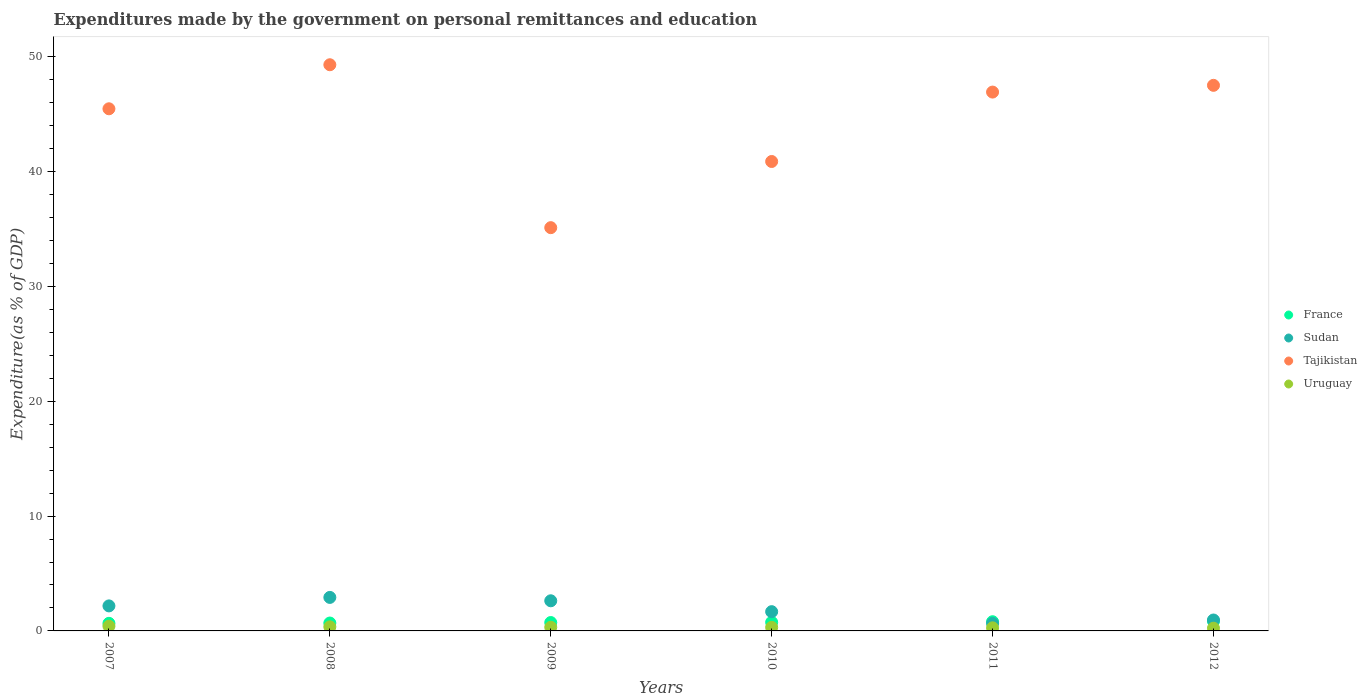How many different coloured dotlines are there?
Provide a short and direct response. 4. Is the number of dotlines equal to the number of legend labels?
Give a very brief answer. Yes. What is the expenditures made by the government on personal remittances and education in Tajikistan in 2010?
Provide a short and direct response. 40.87. Across all years, what is the maximum expenditures made by the government on personal remittances and education in Sudan?
Your response must be concise. 2.92. Across all years, what is the minimum expenditures made by the government on personal remittances and education in France?
Offer a very short reply. 0.66. In which year was the expenditures made by the government on personal remittances and education in France maximum?
Give a very brief answer. 2012. In which year was the expenditures made by the government on personal remittances and education in Sudan minimum?
Provide a succinct answer. 2011. What is the total expenditures made by the government on personal remittances and education in Uruguay in the graph?
Your answer should be very brief. 1.9. What is the difference between the expenditures made by the government on personal remittances and education in France in 2009 and that in 2012?
Keep it short and to the point. -0.12. What is the difference between the expenditures made by the government on personal remittances and education in France in 2008 and the expenditures made by the government on personal remittances and education in Uruguay in 2010?
Your answer should be very brief. 0.38. What is the average expenditures made by the government on personal remittances and education in Tajikistan per year?
Offer a very short reply. 44.19. In the year 2010, what is the difference between the expenditures made by the government on personal remittances and education in Sudan and expenditures made by the government on personal remittances and education in Tajikistan?
Ensure brevity in your answer.  -39.19. What is the ratio of the expenditures made by the government on personal remittances and education in Tajikistan in 2009 to that in 2010?
Keep it short and to the point. 0.86. Is the difference between the expenditures made by the government on personal remittances and education in Sudan in 2007 and 2011 greater than the difference between the expenditures made by the government on personal remittances and education in Tajikistan in 2007 and 2011?
Give a very brief answer. Yes. What is the difference between the highest and the second highest expenditures made by the government on personal remittances and education in France?
Your answer should be compact. 0.04. What is the difference between the highest and the lowest expenditures made by the government on personal remittances and education in France?
Offer a very short reply. 0.19. Is it the case that in every year, the sum of the expenditures made by the government on personal remittances and education in France and expenditures made by the government on personal remittances and education in Uruguay  is greater than the expenditures made by the government on personal remittances and education in Tajikistan?
Keep it short and to the point. No. How many years are there in the graph?
Provide a short and direct response. 6. Does the graph contain any zero values?
Provide a short and direct response. No. Does the graph contain grids?
Keep it short and to the point. No. Where does the legend appear in the graph?
Make the answer very short. Center right. How are the legend labels stacked?
Provide a succinct answer. Vertical. What is the title of the graph?
Make the answer very short. Expenditures made by the government on personal remittances and education. What is the label or title of the Y-axis?
Your answer should be very brief. Expenditure(as % of GDP). What is the Expenditure(as % of GDP) in France in 2007?
Offer a terse response. 0.66. What is the Expenditure(as % of GDP) in Sudan in 2007?
Give a very brief answer. 2.18. What is the Expenditure(as % of GDP) in Tajikistan in 2007?
Your answer should be compact. 45.46. What is the Expenditure(as % of GDP) in Uruguay in 2007?
Make the answer very short. 0.41. What is the Expenditure(as % of GDP) in France in 2008?
Provide a short and direct response. 0.69. What is the Expenditure(as % of GDP) of Sudan in 2008?
Your answer should be very brief. 2.92. What is the Expenditure(as % of GDP) of Tajikistan in 2008?
Give a very brief answer. 49.29. What is the Expenditure(as % of GDP) of Uruguay in 2008?
Provide a short and direct response. 0.36. What is the Expenditure(as % of GDP) in France in 2009?
Your response must be concise. 0.73. What is the Expenditure(as % of GDP) of Sudan in 2009?
Make the answer very short. 2.62. What is the Expenditure(as % of GDP) of Tajikistan in 2009?
Your answer should be compact. 35.11. What is the Expenditure(as % of GDP) of Uruguay in 2009?
Your response must be concise. 0.32. What is the Expenditure(as % of GDP) in France in 2010?
Your response must be concise. 0.75. What is the Expenditure(as % of GDP) of Sudan in 2010?
Ensure brevity in your answer.  1.68. What is the Expenditure(as % of GDP) in Tajikistan in 2010?
Give a very brief answer. 40.87. What is the Expenditure(as % of GDP) in Uruguay in 2010?
Offer a very short reply. 0.31. What is the Expenditure(as % of GDP) of France in 2011?
Your response must be concise. 0.8. What is the Expenditure(as % of GDP) of Sudan in 2011?
Ensure brevity in your answer.  0.66. What is the Expenditure(as % of GDP) of Tajikistan in 2011?
Your answer should be compact. 46.91. What is the Expenditure(as % of GDP) of Uruguay in 2011?
Provide a succinct answer. 0.27. What is the Expenditure(as % of GDP) of France in 2012?
Your answer should be very brief. 0.85. What is the Expenditure(as % of GDP) in Sudan in 2012?
Make the answer very short. 0.95. What is the Expenditure(as % of GDP) in Tajikistan in 2012?
Provide a succinct answer. 47.5. What is the Expenditure(as % of GDP) in Uruguay in 2012?
Provide a succinct answer. 0.24. Across all years, what is the maximum Expenditure(as % of GDP) of France?
Ensure brevity in your answer.  0.85. Across all years, what is the maximum Expenditure(as % of GDP) in Sudan?
Your answer should be very brief. 2.92. Across all years, what is the maximum Expenditure(as % of GDP) in Tajikistan?
Your answer should be compact. 49.29. Across all years, what is the maximum Expenditure(as % of GDP) in Uruguay?
Your answer should be compact. 0.41. Across all years, what is the minimum Expenditure(as % of GDP) of France?
Ensure brevity in your answer.  0.66. Across all years, what is the minimum Expenditure(as % of GDP) in Sudan?
Offer a very short reply. 0.66. Across all years, what is the minimum Expenditure(as % of GDP) of Tajikistan?
Make the answer very short. 35.11. Across all years, what is the minimum Expenditure(as % of GDP) of Uruguay?
Ensure brevity in your answer.  0.24. What is the total Expenditure(as % of GDP) in France in the graph?
Your response must be concise. 4.48. What is the total Expenditure(as % of GDP) of Sudan in the graph?
Offer a terse response. 11. What is the total Expenditure(as % of GDP) in Tajikistan in the graph?
Your answer should be compact. 265.13. What is the total Expenditure(as % of GDP) in Uruguay in the graph?
Offer a very short reply. 1.9. What is the difference between the Expenditure(as % of GDP) of France in 2007 and that in 2008?
Your answer should be very brief. -0.03. What is the difference between the Expenditure(as % of GDP) in Sudan in 2007 and that in 2008?
Your answer should be very brief. -0.74. What is the difference between the Expenditure(as % of GDP) of Tajikistan in 2007 and that in 2008?
Offer a terse response. -3.83. What is the difference between the Expenditure(as % of GDP) of Uruguay in 2007 and that in 2008?
Offer a terse response. 0.06. What is the difference between the Expenditure(as % of GDP) of France in 2007 and that in 2009?
Offer a very short reply. -0.07. What is the difference between the Expenditure(as % of GDP) of Sudan in 2007 and that in 2009?
Keep it short and to the point. -0.45. What is the difference between the Expenditure(as % of GDP) of Tajikistan in 2007 and that in 2009?
Keep it short and to the point. 10.35. What is the difference between the Expenditure(as % of GDP) in Uruguay in 2007 and that in 2009?
Your answer should be compact. 0.09. What is the difference between the Expenditure(as % of GDP) of France in 2007 and that in 2010?
Your response must be concise. -0.09. What is the difference between the Expenditure(as % of GDP) in Sudan in 2007 and that in 2010?
Make the answer very short. 0.5. What is the difference between the Expenditure(as % of GDP) of Tajikistan in 2007 and that in 2010?
Ensure brevity in your answer.  4.59. What is the difference between the Expenditure(as % of GDP) in Uruguay in 2007 and that in 2010?
Keep it short and to the point. 0.1. What is the difference between the Expenditure(as % of GDP) of France in 2007 and that in 2011?
Offer a terse response. -0.14. What is the difference between the Expenditure(as % of GDP) of Sudan in 2007 and that in 2011?
Provide a short and direct response. 1.52. What is the difference between the Expenditure(as % of GDP) in Tajikistan in 2007 and that in 2011?
Offer a very short reply. -1.45. What is the difference between the Expenditure(as % of GDP) in Uruguay in 2007 and that in 2011?
Give a very brief answer. 0.14. What is the difference between the Expenditure(as % of GDP) in France in 2007 and that in 2012?
Provide a short and direct response. -0.19. What is the difference between the Expenditure(as % of GDP) in Sudan in 2007 and that in 2012?
Make the answer very short. 1.23. What is the difference between the Expenditure(as % of GDP) of Tajikistan in 2007 and that in 2012?
Keep it short and to the point. -2.04. What is the difference between the Expenditure(as % of GDP) in Uruguay in 2007 and that in 2012?
Make the answer very short. 0.18. What is the difference between the Expenditure(as % of GDP) of France in 2008 and that in 2009?
Your response must be concise. -0.04. What is the difference between the Expenditure(as % of GDP) in Sudan in 2008 and that in 2009?
Your answer should be very brief. 0.29. What is the difference between the Expenditure(as % of GDP) of Tajikistan in 2008 and that in 2009?
Offer a terse response. 14.18. What is the difference between the Expenditure(as % of GDP) in Uruguay in 2008 and that in 2009?
Your response must be concise. 0.04. What is the difference between the Expenditure(as % of GDP) of France in 2008 and that in 2010?
Offer a terse response. -0.06. What is the difference between the Expenditure(as % of GDP) of Sudan in 2008 and that in 2010?
Make the answer very short. 1.24. What is the difference between the Expenditure(as % of GDP) in Tajikistan in 2008 and that in 2010?
Your response must be concise. 8.42. What is the difference between the Expenditure(as % of GDP) in Uruguay in 2008 and that in 2010?
Keep it short and to the point. 0.05. What is the difference between the Expenditure(as % of GDP) of France in 2008 and that in 2011?
Provide a short and direct response. -0.11. What is the difference between the Expenditure(as % of GDP) of Sudan in 2008 and that in 2011?
Make the answer very short. 2.26. What is the difference between the Expenditure(as % of GDP) in Tajikistan in 2008 and that in 2011?
Offer a terse response. 2.38. What is the difference between the Expenditure(as % of GDP) of Uruguay in 2008 and that in 2011?
Ensure brevity in your answer.  0.09. What is the difference between the Expenditure(as % of GDP) of France in 2008 and that in 2012?
Provide a succinct answer. -0.16. What is the difference between the Expenditure(as % of GDP) of Sudan in 2008 and that in 2012?
Provide a short and direct response. 1.97. What is the difference between the Expenditure(as % of GDP) in Tajikistan in 2008 and that in 2012?
Make the answer very short. 1.79. What is the difference between the Expenditure(as % of GDP) in Uruguay in 2008 and that in 2012?
Provide a succinct answer. 0.12. What is the difference between the Expenditure(as % of GDP) of France in 2009 and that in 2010?
Give a very brief answer. -0.02. What is the difference between the Expenditure(as % of GDP) in Sudan in 2009 and that in 2010?
Your answer should be compact. 0.95. What is the difference between the Expenditure(as % of GDP) of Tajikistan in 2009 and that in 2010?
Your answer should be compact. -5.76. What is the difference between the Expenditure(as % of GDP) of Uruguay in 2009 and that in 2010?
Offer a terse response. 0.01. What is the difference between the Expenditure(as % of GDP) of France in 2009 and that in 2011?
Give a very brief answer. -0.07. What is the difference between the Expenditure(as % of GDP) of Sudan in 2009 and that in 2011?
Your answer should be compact. 1.97. What is the difference between the Expenditure(as % of GDP) of Tajikistan in 2009 and that in 2011?
Offer a terse response. -11.8. What is the difference between the Expenditure(as % of GDP) of Uruguay in 2009 and that in 2011?
Your response must be concise. 0.05. What is the difference between the Expenditure(as % of GDP) in France in 2009 and that in 2012?
Offer a terse response. -0.12. What is the difference between the Expenditure(as % of GDP) in Sudan in 2009 and that in 2012?
Give a very brief answer. 1.67. What is the difference between the Expenditure(as % of GDP) of Tajikistan in 2009 and that in 2012?
Provide a short and direct response. -12.39. What is the difference between the Expenditure(as % of GDP) in Uruguay in 2009 and that in 2012?
Give a very brief answer. 0.08. What is the difference between the Expenditure(as % of GDP) in France in 2010 and that in 2011?
Make the answer very short. -0.05. What is the difference between the Expenditure(as % of GDP) of Sudan in 2010 and that in 2011?
Offer a very short reply. 1.02. What is the difference between the Expenditure(as % of GDP) in Tajikistan in 2010 and that in 2011?
Your answer should be compact. -6.04. What is the difference between the Expenditure(as % of GDP) in Uruguay in 2010 and that in 2011?
Your answer should be very brief. 0.04. What is the difference between the Expenditure(as % of GDP) of France in 2010 and that in 2012?
Give a very brief answer. -0.09. What is the difference between the Expenditure(as % of GDP) in Sudan in 2010 and that in 2012?
Keep it short and to the point. 0.73. What is the difference between the Expenditure(as % of GDP) of Tajikistan in 2010 and that in 2012?
Offer a terse response. -6.63. What is the difference between the Expenditure(as % of GDP) in Uruguay in 2010 and that in 2012?
Offer a very short reply. 0.07. What is the difference between the Expenditure(as % of GDP) in France in 2011 and that in 2012?
Your answer should be compact. -0.04. What is the difference between the Expenditure(as % of GDP) in Sudan in 2011 and that in 2012?
Make the answer very short. -0.29. What is the difference between the Expenditure(as % of GDP) in Tajikistan in 2011 and that in 2012?
Offer a terse response. -0.59. What is the difference between the Expenditure(as % of GDP) of Uruguay in 2011 and that in 2012?
Provide a short and direct response. 0.03. What is the difference between the Expenditure(as % of GDP) of France in 2007 and the Expenditure(as % of GDP) of Sudan in 2008?
Your response must be concise. -2.26. What is the difference between the Expenditure(as % of GDP) of France in 2007 and the Expenditure(as % of GDP) of Tajikistan in 2008?
Offer a terse response. -48.63. What is the difference between the Expenditure(as % of GDP) of France in 2007 and the Expenditure(as % of GDP) of Uruguay in 2008?
Provide a short and direct response. 0.31. What is the difference between the Expenditure(as % of GDP) of Sudan in 2007 and the Expenditure(as % of GDP) of Tajikistan in 2008?
Provide a short and direct response. -47.11. What is the difference between the Expenditure(as % of GDP) in Sudan in 2007 and the Expenditure(as % of GDP) in Uruguay in 2008?
Provide a short and direct response. 1.82. What is the difference between the Expenditure(as % of GDP) in Tajikistan in 2007 and the Expenditure(as % of GDP) in Uruguay in 2008?
Make the answer very short. 45.1. What is the difference between the Expenditure(as % of GDP) in France in 2007 and the Expenditure(as % of GDP) in Sudan in 2009?
Offer a terse response. -1.96. What is the difference between the Expenditure(as % of GDP) in France in 2007 and the Expenditure(as % of GDP) in Tajikistan in 2009?
Keep it short and to the point. -34.45. What is the difference between the Expenditure(as % of GDP) of France in 2007 and the Expenditure(as % of GDP) of Uruguay in 2009?
Offer a terse response. 0.34. What is the difference between the Expenditure(as % of GDP) in Sudan in 2007 and the Expenditure(as % of GDP) in Tajikistan in 2009?
Make the answer very short. -32.93. What is the difference between the Expenditure(as % of GDP) of Sudan in 2007 and the Expenditure(as % of GDP) of Uruguay in 2009?
Provide a short and direct response. 1.86. What is the difference between the Expenditure(as % of GDP) in Tajikistan in 2007 and the Expenditure(as % of GDP) in Uruguay in 2009?
Ensure brevity in your answer.  45.14. What is the difference between the Expenditure(as % of GDP) in France in 2007 and the Expenditure(as % of GDP) in Sudan in 2010?
Your answer should be compact. -1.02. What is the difference between the Expenditure(as % of GDP) of France in 2007 and the Expenditure(as % of GDP) of Tajikistan in 2010?
Offer a terse response. -40.21. What is the difference between the Expenditure(as % of GDP) of France in 2007 and the Expenditure(as % of GDP) of Uruguay in 2010?
Your response must be concise. 0.35. What is the difference between the Expenditure(as % of GDP) of Sudan in 2007 and the Expenditure(as % of GDP) of Tajikistan in 2010?
Offer a very short reply. -38.69. What is the difference between the Expenditure(as % of GDP) in Sudan in 2007 and the Expenditure(as % of GDP) in Uruguay in 2010?
Keep it short and to the point. 1.87. What is the difference between the Expenditure(as % of GDP) in Tajikistan in 2007 and the Expenditure(as % of GDP) in Uruguay in 2010?
Offer a very short reply. 45.15. What is the difference between the Expenditure(as % of GDP) in France in 2007 and the Expenditure(as % of GDP) in Sudan in 2011?
Make the answer very short. 0. What is the difference between the Expenditure(as % of GDP) in France in 2007 and the Expenditure(as % of GDP) in Tajikistan in 2011?
Your response must be concise. -46.25. What is the difference between the Expenditure(as % of GDP) in France in 2007 and the Expenditure(as % of GDP) in Uruguay in 2011?
Provide a succinct answer. 0.39. What is the difference between the Expenditure(as % of GDP) in Sudan in 2007 and the Expenditure(as % of GDP) in Tajikistan in 2011?
Offer a very short reply. -44.73. What is the difference between the Expenditure(as % of GDP) of Sudan in 2007 and the Expenditure(as % of GDP) of Uruguay in 2011?
Make the answer very short. 1.91. What is the difference between the Expenditure(as % of GDP) of Tajikistan in 2007 and the Expenditure(as % of GDP) of Uruguay in 2011?
Your answer should be compact. 45.19. What is the difference between the Expenditure(as % of GDP) of France in 2007 and the Expenditure(as % of GDP) of Sudan in 2012?
Provide a succinct answer. -0.29. What is the difference between the Expenditure(as % of GDP) in France in 2007 and the Expenditure(as % of GDP) in Tajikistan in 2012?
Your response must be concise. -46.84. What is the difference between the Expenditure(as % of GDP) of France in 2007 and the Expenditure(as % of GDP) of Uruguay in 2012?
Offer a terse response. 0.42. What is the difference between the Expenditure(as % of GDP) of Sudan in 2007 and the Expenditure(as % of GDP) of Tajikistan in 2012?
Your response must be concise. -45.32. What is the difference between the Expenditure(as % of GDP) in Sudan in 2007 and the Expenditure(as % of GDP) in Uruguay in 2012?
Make the answer very short. 1.94. What is the difference between the Expenditure(as % of GDP) in Tajikistan in 2007 and the Expenditure(as % of GDP) in Uruguay in 2012?
Provide a short and direct response. 45.22. What is the difference between the Expenditure(as % of GDP) of France in 2008 and the Expenditure(as % of GDP) of Sudan in 2009?
Keep it short and to the point. -1.94. What is the difference between the Expenditure(as % of GDP) of France in 2008 and the Expenditure(as % of GDP) of Tajikistan in 2009?
Ensure brevity in your answer.  -34.42. What is the difference between the Expenditure(as % of GDP) in France in 2008 and the Expenditure(as % of GDP) in Uruguay in 2009?
Your answer should be compact. 0.37. What is the difference between the Expenditure(as % of GDP) of Sudan in 2008 and the Expenditure(as % of GDP) of Tajikistan in 2009?
Ensure brevity in your answer.  -32.19. What is the difference between the Expenditure(as % of GDP) in Sudan in 2008 and the Expenditure(as % of GDP) in Uruguay in 2009?
Your answer should be very brief. 2.6. What is the difference between the Expenditure(as % of GDP) in Tajikistan in 2008 and the Expenditure(as % of GDP) in Uruguay in 2009?
Provide a succinct answer. 48.97. What is the difference between the Expenditure(as % of GDP) of France in 2008 and the Expenditure(as % of GDP) of Sudan in 2010?
Provide a short and direct response. -0.99. What is the difference between the Expenditure(as % of GDP) of France in 2008 and the Expenditure(as % of GDP) of Tajikistan in 2010?
Provide a short and direct response. -40.18. What is the difference between the Expenditure(as % of GDP) in France in 2008 and the Expenditure(as % of GDP) in Uruguay in 2010?
Offer a terse response. 0.38. What is the difference between the Expenditure(as % of GDP) of Sudan in 2008 and the Expenditure(as % of GDP) of Tajikistan in 2010?
Your answer should be compact. -37.95. What is the difference between the Expenditure(as % of GDP) in Sudan in 2008 and the Expenditure(as % of GDP) in Uruguay in 2010?
Provide a succinct answer. 2.61. What is the difference between the Expenditure(as % of GDP) in Tajikistan in 2008 and the Expenditure(as % of GDP) in Uruguay in 2010?
Make the answer very short. 48.98. What is the difference between the Expenditure(as % of GDP) in France in 2008 and the Expenditure(as % of GDP) in Sudan in 2011?
Ensure brevity in your answer.  0.03. What is the difference between the Expenditure(as % of GDP) in France in 2008 and the Expenditure(as % of GDP) in Tajikistan in 2011?
Provide a short and direct response. -46.22. What is the difference between the Expenditure(as % of GDP) in France in 2008 and the Expenditure(as % of GDP) in Uruguay in 2011?
Give a very brief answer. 0.42. What is the difference between the Expenditure(as % of GDP) in Sudan in 2008 and the Expenditure(as % of GDP) in Tajikistan in 2011?
Provide a succinct answer. -43.99. What is the difference between the Expenditure(as % of GDP) of Sudan in 2008 and the Expenditure(as % of GDP) of Uruguay in 2011?
Provide a short and direct response. 2.65. What is the difference between the Expenditure(as % of GDP) in Tajikistan in 2008 and the Expenditure(as % of GDP) in Uruguay in 2011?
Make the answer very short. 49.02. What is the difference between the Expenditure(as % of GDP) of France in 2008 and the Expenditure(as % of GDP) of Sudan in 2012?
Provide a succinct answer. -0.26. What is the difference between the Expenditure(as % of GDP) in France in 2008 and the Expenditure(as % of GDP) in Tajikistan in 2012?
Make the answer very short. -46.81. What is the difference between the Expenditure(as % of GDP) in France in 2008 and the Expenditure(as % of GDP) in Uruguay in 2012?
Keep it short and to the point. 0.45. What is the difference between the Expenditure(as % of GDP) of Sudan in 2008 and the Expenditure(as % of GDP) of Tajikistan in 2012?
Offer a very short reply. -44.58. What is the difference between the Expenditure(as % of GDP) in Sudan in 2008 and the Expenditure(as % of GDP) in Uruguay in 2012?
Your answer should be very brief. 2.68. What is the difference between the Expenditure(as % of GDP) of Tajikistan in 2008 and the Expenditure(as % of GDP) of Uruguay in 2012?
Provide a short and direct response. 49.05. What is the difference between the Expenditure(as % of GDP) of France in 2009 and the Expenditure(as % of GDP) of Sudan in 2010?
Make the answer very short. -0.95. What is the difference between the Expenditure(as % of GDP) in France in 2009 and the Expenditure(as % of GDP) in Tajikistan in 2010?
Provide a short and direct response. -40.14. What is the difference between the Expenditure(as % of GDP) of France in 2009 and the Expenditure(as % of GDP) of Uruguay in 2010?
Offer a very short reply. 0.42. What is the difference between the Expenditure(as % of GDP) of Sudan in 2009 and the Expenditure(as % of GDP) of Tajikistan in 2010?
Your answer should be very brief. -38.24. What is the difference between the Expenditure(as % of GDP) in Sudan in 2009 and the Expenditure(as % of GDP) in Uruguay in 2010?
Your answer should be compact. 2.31. What is the difference between the Expenditure(as % of GDP) in Tajikistan in 2009 and the Expenditure(as % of GDP) in Uruguay in 2010?
Make the answer very short. 34.8. What is the difference between the Expenditure(as % of GDP) in France in 2009 and the Expenditure(as % of GDP) in Sudan in 2011?
Provide a short and direct response. 0.07. What is the difference between the Expenditure(as % of GDP) in France in 2009 and the Expenditure(as % of GDP) in Tajikistan in 2011?
Offer a very short reply. -46.18. What is the difference between the Expenditure(as % of GDP) of France in 2009 and the Expenditure(as % of GDP) of Uruguay in 2011?
Your answer should be compact. 0.46. What is the difference between the Expenditure(as % of GDP) of Sudan in 2009 and the Expenditure(as % of GDP) of Tajikistan in 2011?
Your answer should be compact. -44.29. What is the difference between the Expenditure(as % of GDP) in Sudan in 2009 and the Expenditure(as % of GDP) in Uruguay in 2011?
Your answer should be compact. 2.35. What is the difference between the Expenditure(as % of GDP) in Tajikistan in 2009 and the Expenditure(as % of GDP) in Uruguay in 2011?
Make the answer very short. 34.84. What is the difference between the Expenditure(as % of GDP) in France in 2009 and the Expenditure(as % of GDP) in Sudan in 2012?
Provide a short and direct response. -0.22. What is the difference between the Expenditure(as % of GDP) of France in 2009 and the Expenditure(as % of GDP) of Tajikistan in 2012?
Provide a succinct answer. -46.77. What is the difference between the Expenditure(as % of GDP) in France in 2009 and the Expenditure(as % of GDP) in Uruguay in 2012?
Provide a short and direct response. 0.49. What is the difference between the Expenditure(as % of GDP) of Sudan in 2009 and the Expenditure(as % of GDP) of Tajikistan in 2012?
Give a very brief answer. -44.87. What is the difference between the Expenditure(as % of GDP) in Sudan in 2009 and the Expenditure(as % of GDP) in Uruguay in 2012?
Provide a succinct answer. 2.39. What is the difference between the Expenditure(as % of GDP) in Tajikistan in 2009 and the Expenditure(as % of GDP) in Uruguay in 2012?
Make the answer very short. 34.87. What is the difference between the Expenditure(as % of GDP) of France in 2010 and the Expenditure(as % of GDP) of Sudan in 2011?
Keep it short and to the point. 0.1. What is the difference between the Expenditure(as % of GDP) of France in 2010 and the Expenditure(as % of GDP) of Tajikistan in 2011?
Offer a very short reply. -46.16. What is the difference between the Expenditure(as % of GDP) of France in 2010 and the Expenditure(as % of GDP) of Uruguay in 2011?
Give a very brief answer. 0.48. What is the difference between the Expenditure(as % of GDP) of Sudan in 2010 and the Expenditure(as % of GDP) of Tajikistan in 2011?
Your answer should be compact. -45.23. What is the difference between the Expenditure(as % of GDP) in Sudan in 2010 and the Expenditure(as % of GDP) in Uruguay in 2011?
Offer a very short reply. 1.41. What is the difference between the Expenditure(as % of GDP) of Tajikistan in 2010 and the Expenditure(as % of GDP) of Uruguay in 2011?
Provide a short and direct response. 40.6. What is the difference between the Expenditure(as % of GDP) of France in 2010 and the Expenditure(as % of GDP) of Sudan in 2012?
Provide a succinct answer. -0.2. What is the difference between the Expenditure(as % of GDP) in France in 2010 and the Expenditure(as % of GDP) in Tajikistan in 2012?
Your answer should be very brief. -46.75. What is the difference between the Expenditure(as % of GDP) in France in 2010 and the Expenditure(as % of GDP) in Uruguay in 2012?
Give a very brief answer. 0.51. What is the difference between the Expenditure(as % of GDP) of Sudan in 2010 and the Expenditure(as % of GDP) of Tajikistan in 2012?
Ensure brevity in your answer.  -45.82. What is the difference between the Expenditure(as % of GDP) of Sudan in 2010 and the Expenditure(as % of GDP) of Uruguay in 2012?
Offer a very short reply. 1.44. What is the difference between the Expenditure(as % of GDP) of Tajikistan in 2010 and the Expenditure(as % of GDP) of Uruguay in 2012?
Give a very brief answer. 40.63. What is the difference between the Expenditure(as % of GDP) in France in 2011 and the Expenditure(as % of GDP) in Sudan in 2012?
Ensure brevity in your answer.  -0.15. What is the difference between the Expenditure(as % of GDP) of France in 2011 and the Expenditure(as % of GDP) of Tajikistan in 2012?
Offer a very short reply. -46.7. What is the difference between the Expenditure(as % of GDP) of France in 2011 and the Expenditure(as % of GDP) of Uruguay in 2012?
Make the answer very short. 0.56. What is the difference between the Expenditure(as % of GDP) of Sudan in 2011 and the Expenditure(as % of GDP) of Tajikistan in 2012?
Your answer should be very brief. -46.84. What is the difference between the Expenditure(as % of GDP) in Sudan in 2011 and the Expenditure(as % of GDP) in Uruguay in 2012?
Provide a short and direct response. 0.42. What is the difference between the Expenditure(as % of GDP) in Tajikistan in 2011 and the Expenditure(as % of GDP) in Uruguay in 2012?
Ensure brevity in your answer.  46.67. What is the average Expenditure(as % of GDP) of France per year?
Keep it short and to the point. 0.75. What is the average Expenditure(as % of GDP) in Sudan per year?
Make the answer very short. 1.83. What is the average Expenditure(as % of GDP) of Tajikistan per year?
Offer a very short reply. 44.19. What is the average Expenditure(as % of GDP) in Uruguay per year?
Provide a short and direct response. 0.32. In the year 2007, what is the difference between the Expenditure(as % of GDP) of France and Expenditure(as % of GDP) of Sudan?
Keep it short and to the point. -1.52. In the year 2007, what is the difference between the Expenditure(as % of GDP) of France and Expenditure(as % of GDP) of Tajikistan?
Give a very brief answer. -44.8. In the year 2007, what is the difference between the Expenditure(as % of GDP) of France and Expenditure(as % of GDP) of Uruguay?
Provide a succinct answer. 0.25. In the year 2007, what is the difference between the Expenditure(as % of GDP) in Sudan and Expenditure(as % of GDP) in Tajikistan?
Make the answer very short. -43.28. In the year 2007, what is the difference between the Expenditure(as % of GDP) of Sudan and Expenditure(as % of GDP) of Uruguay?
Your answer should be very brief. 1.77. In the year 2007, what is the difference between the Expenditure(as % of GDP) in Tajikistan and Expenditure(as % of GDP) in Uruguay?
Your answer should be very brief. 45.04. In the year 2008, what is the difference between the Expenditure(as % of GDP) of France and Expenditure(as % of GDP) of Sudan?
Give a very brief answer. -2.23. In the year 2008, what is the difference between the Expenditure(as % of GDP) of France and Expenditure(as % of GDP) of Tajikistan?
Make the answer very short. -48.6. In the year 2008, what is the difference between the Expenditure(as % of GDP) in France and Expenditure(as % of GDP) in Uruguay?
Offer a terse response. 0.33. In the year 2008, what is the difference between the Expenditure(as % of GDP) of Sudan and Expenditure(as % of GDP) of Tajikistan?
Keep it short and to the point. -46.37. In the year 2008, what is the difference between the Expenditure(as % of GDP) of Sudan and Expenditure(as % of GDP) of Uruguay?
Your response must be concise. 2.56. In the year 2008, what is the difference between the Expenditure(as % of GDP) of Tajikistan and Expenditure(as % of GDP) of Uruguay?
Ensure brevity in your answer.  48.93. In the year 2009, what is the difference between the Expenditure(as % of GDP) in France and Expenditure(as % of GDP) in Sudan?
Provide a succinct answer. -1.89. In the year 2009, what is the difference between the Expenditure(as % of GDP) of France and Expenditure(as % of GDP) of Tajikistan?
Offer a terse response. -34.38. In the year 2009, what is the difference between the Expenditure(as % of GDP) of France and Expenditure(as % of GDP) of Uruguay?
Ensure brevity in your answer.  0.41. In the year 2009, what is the difference between the Expenditure(as % of GDP) in Sudan and Expenditure(as % of GDP) in Tajikistan?
Your answer should be compact. -32.48. In the year 2009, what is the difference between the Expenditure(as % of GDP) in Sudan and Expenditure(as % of GDP) in Uruguay?
Offer a very short reply. 2.3. In the year 2009, what is the difference between the Expenditure(as % of GDP) in Tajikistan and Expenditure(as % of GDP) in Uruguay?
Ensure brevity in your answer.  34.79. In the year 2010, what is the difference between the Expenditure(as % of GDP) of France and Expenditure(as % of GDP) of Sudan?
Provide a short and direct response. -0.92. In the year 2010, what is the difference between the Expenditure(as % of GDP) in France and Expenditure(as % of GDP) in Tajikistan?
Your response must be concise. -40.12. In the year 2010, what is the difference between the Expenditure(as % of GDP) in France and Expenditure(as % of GDP) in Uruguay?
Your answer should be very brief. 0.44. In the year 2010, what is the difference between the Expenditure(as % of GDP) of Sudan and Expenditure(as % of GDP) of Tajikistan?
Keep it short and to the point. -39.19. In the year 2010, what is the difference between the Expenditure(as % of GDP) of Sudan and Expenditure(as % of GDP) of Uruguay?
Your answer should be very brief. 1.37. In the year 2010, what is the difference between the Expenditure(as % of GDP) in Tajikistan and Expenditure(as % of GDP) in Uruguay?
Your answer should be compact. 40.56. In the year 2011, what is the difference between the Expenditure(as % of GDP) of France and Expenditure(as % of GDP) of Sudan?
Ensure brevity in your answer.  0.14. In the year 2011, what is the difference between the Expenditure(as % of GDP) of France and Expenditure(as % of GDP) of Tajikistan?
Make the answer very short. -46.11. In the year 2011, what is the difference between the Expenditure(as % of GDP) of France and Expenditure(as % of GDP) of Uruguay?
Provide a short and direct response. 0.53. In the year 2011, what is the difference between the Expenditure(as % of GDP) of Sudan and Expenditure(as % of GDP) of Tajikistan?
Make the answer very short. -46.25. In the year 2011, what is the difference between the Expenditure(as % of GDP) of Sudan and Expenditure(as % of GDP) of Uruguay?
Offer a terse response. 0.39. In the year 2011, what is the difference between the Expenditure(as % of GDP) of Tajikistan and Expenditure(as % of GDP) of Uruguay?
Your answer should be compact. 46.64. In the year 2012, what is the difference between the Expenditure(as % of GDP) in France and Expenditure(as % of GDP) in Sudan?
Your answer should be very brief. -0.1. In the year 2012, what is the difference between the Expenditure(as % of GDP) in France and Expenditure(as % of GDP) in Tajikistan?
Your answer should be very brief. -46.65. In the year 2012, what is the difference between the Expenditure(as % of GDP) of France and Expenditure(as % of GDP) of Uruguay?
Your answer should be very brief. 0.61. In the year 2012, what is the difference between the Expenditure(as % of GDP) in Sudan and Expenditure(as % of GDP) in Tajikistan?
Provide a succinct answer. -46.55. In the year 2012, what is the difference between the Expenditure(as % of GDP) in Sudan and Expenditure(as % of GDP) in Uruguay?
Offer a terse response. 0.71. In the year 2012, what is the difference between the Expenditure(as % of GDP) of Tajikistan and Expenditure(as % of GDP) of Uruguay?
Offer a terse response. 47.26. What is the ratio of the Expenditure(as % of GDP) in France in 2007 to that in 2008?
Offer a terse response. 0.96. What is the ratio of the Expenditure(as % of GDP) of Sudan in 2007 to that in 2008?
Your response must be concise. 0.75. What is the ratio of the Expenditure(as % of GDP) in Tajikistan in 2007 to that in 2008?
Keep it short and to the point. 0.92. What is the ratio of the Expenditure(as % of GDP) in Uruguay in 2007 to that in 2008?
Provide a succinct answer. 1.16. What is the ratio of the Expenditure(as % of GDP) in France in 2007 to that in 2009?
Offer a very short reply. 0.91. What is the ratio of the Expenditure(as % of GDP) in Sudan in 2007 to that in 2009?
Keep it short and to the point. 0.83. What is the ratio of the Expenditure(as % of GDP) in Tajikistan in 2007 to that in 2009?
Make the answer very short. 1.29. What is the ratio of the Expenditure(as % of GDP) in Uruguay in 2007 to that in 2009?
Keep it short and to the point. 1.29. What is the ratio of the Expenditure(as % of GDP) in France in 2007 to that in 2010?
Make the answer very short. 0.88. What is the ratio of the Expenditure(as % of GDP) of Sudan in 2007 to that in 2010?
Your answer should be compact. 1.3. What is the ratio of the Expenditure(as % of GDP) of Tajikistan in 2007 to that in 2010?
Offer a terse response. 1.11. What is the ratio of the Expenditure(as % of GDP) in Uruguay in 2007 to that in 2010?
Keep it short and to the point. 1.33. What is the ratio of the Expenditure(as % of GDP) in France in 2007 to that in 2011?
Keep it short and to the point. 0.82. What is the ratio of the Expenditure(as % of GDP) of Sudan in 2007 to that in 2011?
Keep it short and to the point. 3.32. What is the ratio of the Expenditure(as % of GDP) of Tajikistan in 2007 to that in 2011?
Your answer should be compact. 0.97. What is the ratio of the Expenditure(as % of GDP) in Uruguay in 2007 to that in 2011?
Your response must be concise. 1.53. What is the ratio of the Expenditure(as % of GDP) in France in 2007 to that in 2012?
Keep it short and to the point. 0.78. What is the ratio of the Expenditure(as % of GDP) of Sudan in 2007 to that in 2012?
Your answer should be very brief. 2.29. What is the ratio of the Expenditure(as % of GDP) in Tajikistan in 2007 to that in 2012?
Provide a short and direct response. 0.96. What is the ratio of the Expenditure(as % of GDP) of Uruguay in 2007 to that in 2012?
Offer a terse response. 1.74. What is the ratio of the Expenditure(as % of GDP) in France in 2008 to that in 2009?
Keep it short and to the point. 0.94. What is the ratio of the Expenditure(as % of GDP) in Sudan in 2008 to that in 2009?
Your response must be concise. 1.11. What is the ratio of the Expenditure(as % of GDP) in Tajikistan in 2008 to that in 2009?
Offer a terse response. 1.4. What is the ratio of the Expenditure(as % of GDP) in Uruguay in 2008 to that in 2009?
Make the answer very short. 1.11. What is the ratio of the Expenditure(as % of GDP) in France in 2008 to that in 2010?
Your answer should be very brief. 0.91. What is the ratio of the Expenditure(as % of GDP) in Sudan in 2008 to that in 2010?
Your answer should be compact. 1.74. What is the ratio of the Expenditure(as % of GDP) of Tajikistan in 2008 to that in 2010?
Offer a very short reply. 1.21. What is the ratio of the Expenditure(as % of GDP) in Uruguay in 2008 to that in 2010?
Offer a terse response. 1.15. What is the ratio of the Expenditure(as % of GDP) of France in 2008 to that in 2011?
Provide a short and direct response. 0.86. What is the ratio of the Expenditure(as % of GDP) in Sudan in 2008 to that in 2011?
Offer a very short reply. 4.44. What is the ratio of the Expenditure(as % of GDP) in Tajikistan in 2008 to that in 2011?
Offer a terse response. 1.05. What is the ratio of the Expenditure(as % of GDP) in Uruguay in 2008 to that in 2011?
Offer a very short reply. 1.32. What is the ratio of the Expenditure(as % of GDP) in France in 2008 to that in 2012?
Offer a very short reply. 0.81. What is the ratio of the Expenditure(as % of GDP) of Sudan in 2008 to that in 2012?
Your answer should be very brief. 3.07. What is the ratio of the Expenditure(as % of GDP) of Tajikistan in 2008 to that in 2012?
Offer a very short reply. 1.04. What is the ratio of the Expenditure(as % of GDP) of Uruguay in 2008 to that in 2012?
Make the answer very short. 1.5. What is the ratio of the Expenditure(as % of GDP) of France in 2009 to that in 2010?
Your answer should be compact. 0.97. What is the ratio of the Expenditure(as % of GDP) of Sudan in 2009 to that in 2010?
Your answer should be compact. 1.57. What is the ratio of the Expenditure(as % of GDP) of Tajikistan in 2009 to that in 2010?
Your answer should be compact. 0.86. What is the ratio of the Expenditure(as % of GDP) of Uruguay in 2009 to that in 2010?
Your answer should be compact. 1.03. What is the ratio of the Expenditure(as % of GDP) in France in 2009 to that in 2011?
Ensure brevity in your answer.  0.91. What is the ratio of the Expenditure(as % of GDP) in Sudan in 2009 to that in 2011?
Your answer should be very brief. 4. What is the ratio of the Expenditure(as % of GDP) of Tajikistan in 2009 to that in 2011?
Your answer should be compact. 0.75. What is the ratio of the Expenditure(as % of GDP) of Uruguay in 2009 to that in 2011?
Your answer should be compact. 1.19. What is the ratio of the Expenditure(as % of GDP) in France in 2009 to that in 2012?
Your answer should be compact. 0.86. What is the ratio of the Expenditure(as % of GDP) in Sudan in 2009 to that in 2012?
Provide a short and direct response. 2.76. What is the ratio of the Expenditure(as % of GDP) in Tajikistan in 2009 to that in 2012?
Give a very brief answer. 0.74. What is the ratio of the Expenditure(as % of GDP) in Uruguay in 2009 to that in 2012?
Your answer should be compact. 1.35. What is the ratio of the Expenditure(as % of GDP) of France in 2010 to that in 2011?
Make the answer very short. 0.94. What is the ratio of the Expenditure(as % of GDP) in Sudan in 2010 to that in 2011?
Make the answer very short. 2.55. What is the ratio of the Expenditure(as % of GDP) in Tajikistan in 2010 to that in 2011?
Offer a very short reply. 0.87. What is the ratio of the Expenditure(as % of GDP) of Uruguay in 2010 to that in 2011?
Provide a short and direct response. 1.15. What is the ratio of the Expenditure(as % of GDP) of France in 2010 to that in 2012?
Provide a short and direct response. 0.89. What is the ratio of the Expenditure(as % of GDP) in Sudan in 2010 to that in 2012?
Provide a short and direct response. 1.76. What is the ratio of the Expenditure(as % of GDP) of Tajikistan in 2010 to that in 2012?
Your response must be concise. 0.86. What is the ratio of the Expenditure(as % of GDP) of Uruguay in 2010 to that in 2012?
Give a very brief answer. 1.31. What is the ratio of the Expenditure(as % of GDP) in France in 2011 to that in 2012?
Give a very brief answer. 0.95. What is the ratio of the Expenditure(as % of GDP) of Sudan in 2011 to that in 2012?
Keep it short and to the point. 0.69. What is the ratio of the Expenditure(as % of GDP) of Tajikistan in 2011 to that in 2012?
Provide a short and direct response. 0.99. What is the ratio of the Expenditure(as % of GDP) in Uruguay in 2011 to that in 2012?
Your response must be concise. 1.13. What is the difference between the highest and the second highest Expenditure(as % of GDP) in France?
Ensure brevity in your answer.  0.04. What is the difference between the highest and the second highest Expenditure(as % of GDP) of Sudan?
Give a very brief answer. 0.29. What is the difference between the highest and the second highest Expenditure(as % of GDP) in Tajikistan?
Ensure brevity in your answer.  1.79. What is the difference between the highest and the second highest Expenditure(as % of GDP) of Uruguay?
Provide a short and direct response. 0.06. What is the difference between the highest and the lowest Expenditure(as % of GDP) of France?
Your answer should be compact. 0.19. What is the difference between the highest and the lowest Expenditure(as % of GDP) of Sudan?
Make the answer very short. 2.26. What is the difference between the highest and the lowest Expenditure(as % of GDP) in Tajikistan?
Offer a terse response. 14.18. What is the difference between the highest and the lowest Expenditure(as % of GDP) in Uruguay?
Give a very brief answer. 0.18. 